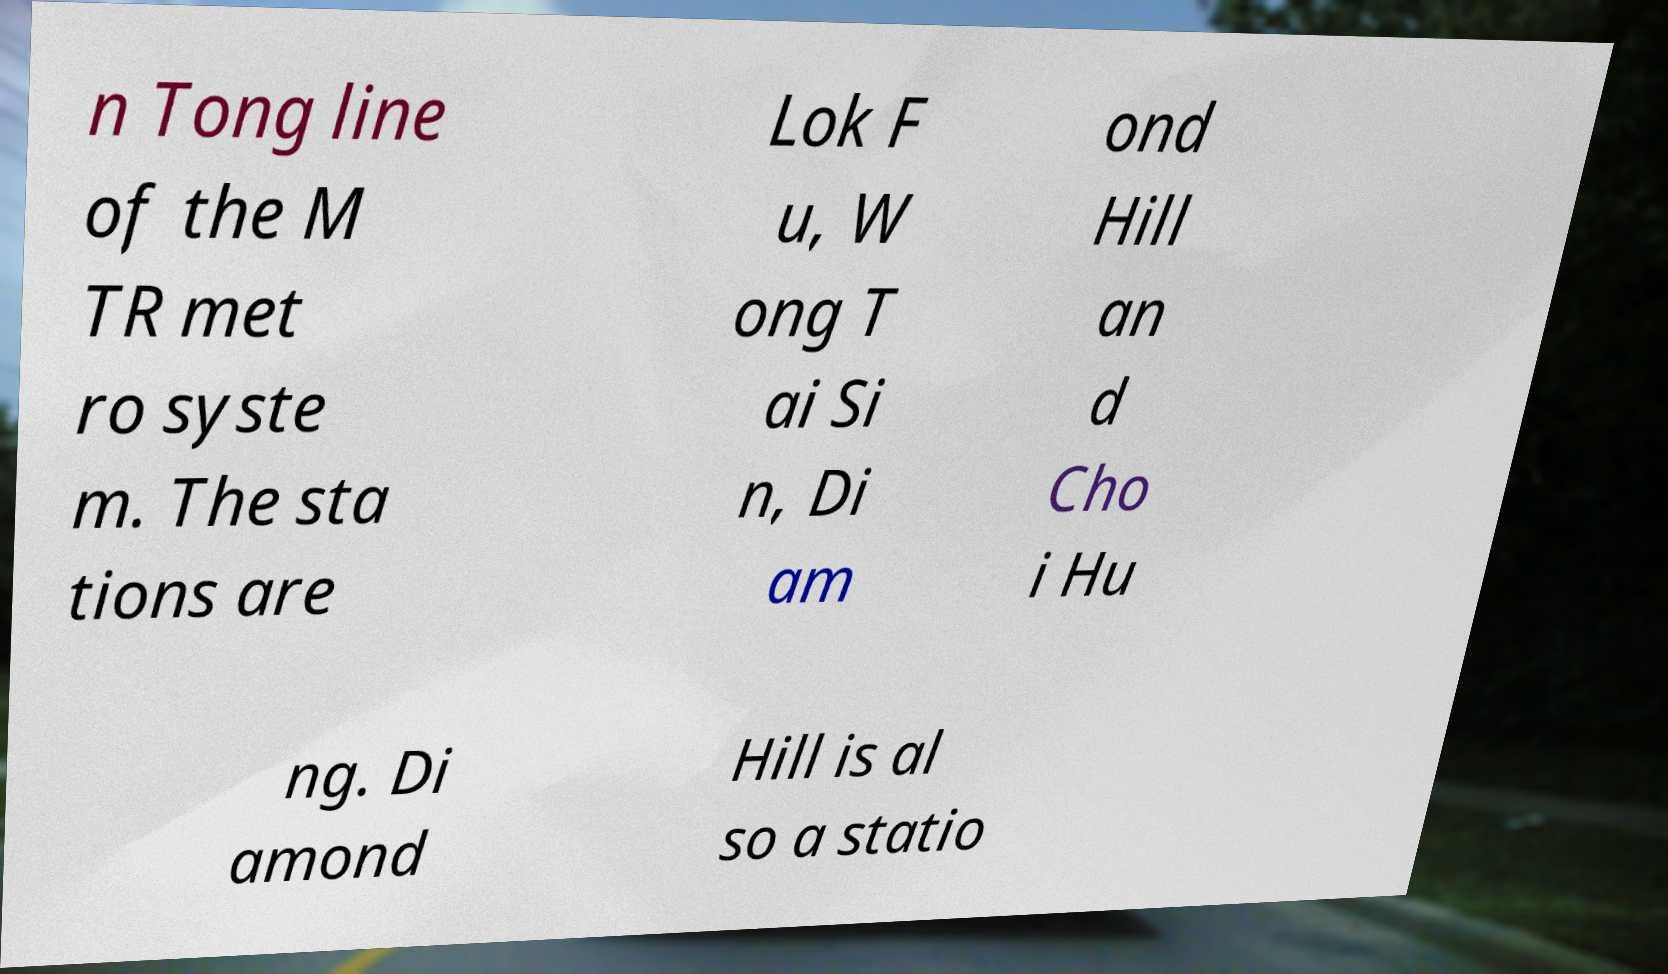Could you extract and type out the text from this image? n Tong line of the M TR met ro syste m. The sta tions are Lok F u, W ong T ai Si n, Di am ond Hill an d Cho i Hu ng. Di amond Hill is al so a statio 